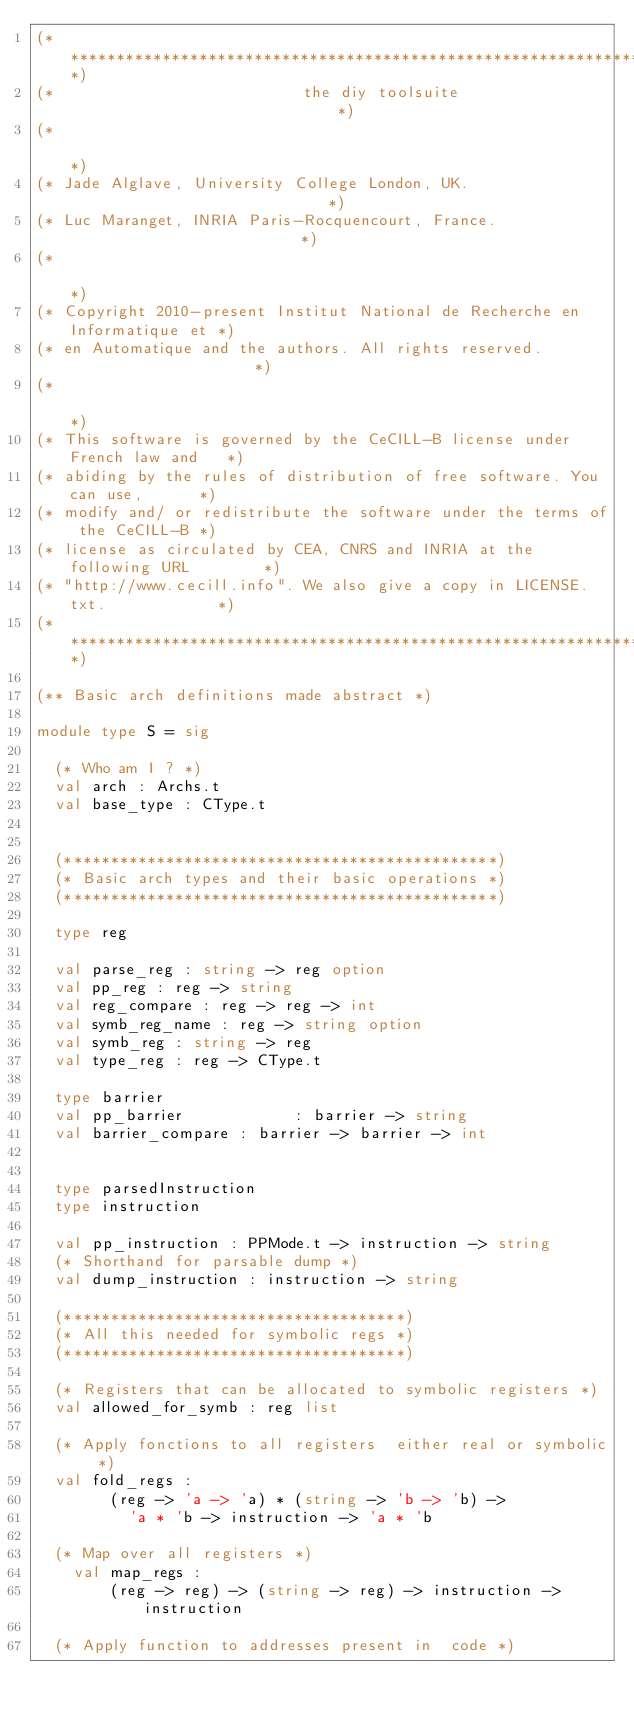Convert code to text. <code><loc_0><loc_0><loc_500><loc_500><_OCaml_>(****************************************************************************)
(*                           the diy toolsuite                              *)
(*                                                                          *)
(* Jade Alglave, University College London, UK.                             *)
(* Luc Maranget, INRIA Paris-Rocquencourt, France.                          *)
(*                                                                          *)
(* Copyright 2010-present Institut National de Recherche en Informatique et *)
(* en Automatique and the authors. All rights reserved.                     *)
(*                                                                          *)
(* This software is governed by the CeCILL-B license under French law and   *)
(* abiding by the rules of distribution of free software. You can use,      *)
(* modify and/ or redistribute the software under the terms of the CeCILL-B *)
(* license as circulated by CEA, CNRS and INRIA at the following URL        *)
(* "http://www.cecill.info". We also give a copy in LICENSE.txt.            *)
(****************************************************************************)

(** Basic arch definitions made abstract *)

module type S = sig

  (* Who am I ? *)
  val arch : Archs.t
  val base_type : CType.t


  (***********************************************)
  (* Basic arch types and their basic operations *)
  (***********************************************)

  type reg

  val parse_reg : string -> reg option
  val pp_reg : reg -> string
  val reg_compare : reg -> reg -> int
  val symb_reg_name : reg -> string option
  val symb_reg : string -> reg
  val type_reg : reg -> CType.t

  type barrier
  val pp_barrier            : barrier -> string
  val barrier_compare : barrier -> barrier -> int


  type parsedInstruction
  type instruction

  val pp_instruction : PPMode.t -> instruction -> string
  (* Shorthand for parsable dump *)
  val dump_instruction : instruction -> string

  (*************************************)
  (* All this needed for symbolic regs *)
  (*************************************)

  (* Registers that can be allocated to symbolic registers *)
  val allowed_for_symb : reg list

  (* Apply fonctions to all registers  either real or symbolic *)
  val fold_regs :
        (reg -> 'a -> 'a) * (string -> 'b -> 'b) ->
          'a * 'b -> instruction -> 'a * 'b

  (* Map over all registers *)
    val map_regs :
        (reg -> reg) -> (string -> reg) -> instruction -> instruction

  (* Apply function to addresses present in  code *)</code> 